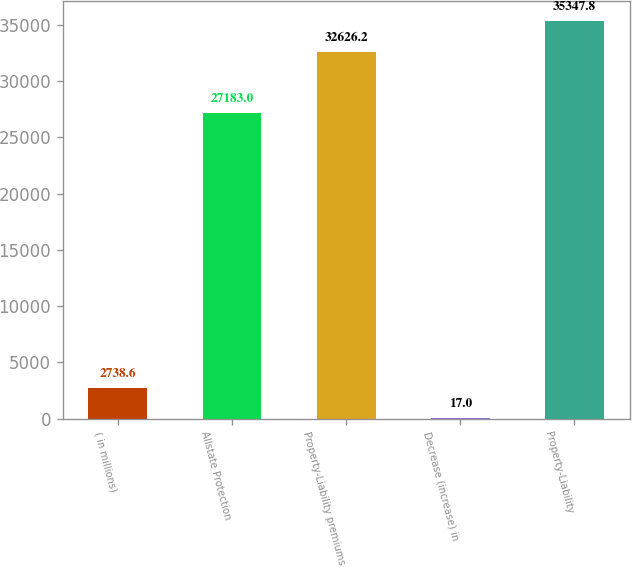Convert chart. <chart><loc_0><loc_0><loc_500><loc_500><bar_chart><fcel>( in millions)<fcel>Allstate Protection<fcel>Property-Liability premiums<fcel>Decrease (increase) in<fcel>Property-Liability<nl><fcel>2738.6<fcel>27183<fcel>32626.2<fcel>17<fcel>35347.8<nl></chart> 